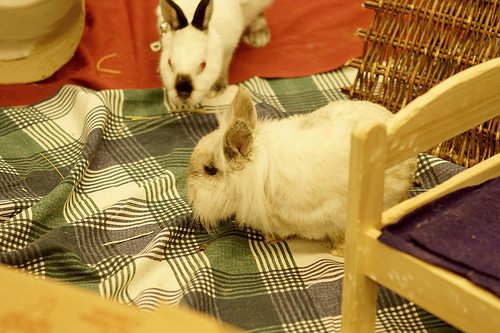<image>
Is the rabbit in the blanket? No. The rabbit is not contained within the blanket. These objects have a different spatial relationship. Where is the rabbit in relation to the bed sheet? Is it in the bed sheet? No. The rabbit is not contained within the bed sheet. These objects have a different spatial relationship. Is there a bunny in front of the bed? No. The bunny is not in front of the bed. The spatial positioning shows a different relationship between these objects. 